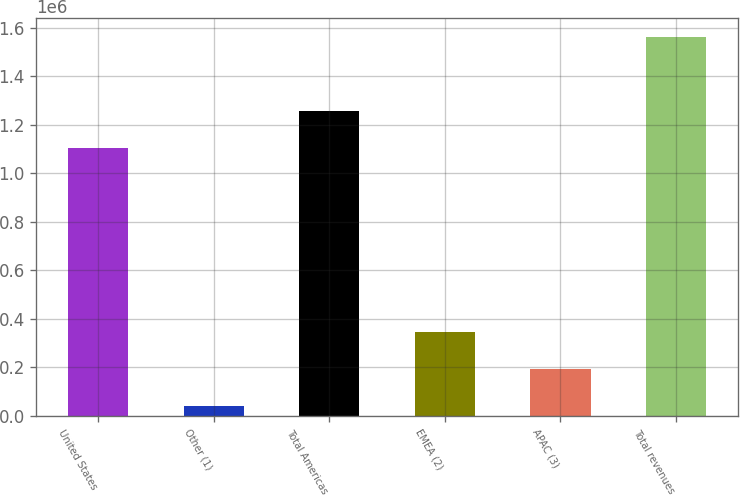Convert chart to OTSL. <chart><loc_0><loc_0><loc_500><loc_500><bar_chart><fcel>United States<fcel>Other (1)<fcel>Total Americas<fcel>EMEA (2)<fcel>APAC (3)<fcel>Total revenues<nl><fcel>1.10459e+06<fcel>40119<fcel>1.25688e+06<fcel>344695<fcel>192407<fcel>1.563e+06<nl></chart> 